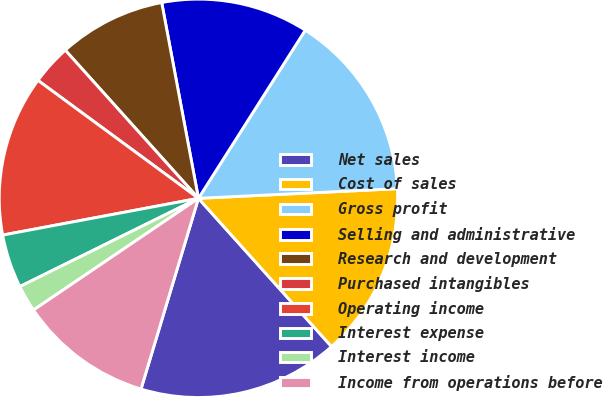<chart> <loc_0><loc_0><loc_500><loc_500><pie_chart><fcel>Net sales<fcel>Cost of sales<fcel>Gross profit<fcel>Selling and administrative<fcel>Research and development<fcel>Purchased intangibles<fcel>Operating income<fcel>Interest expense<fcel>Interest income<fcel>Income from operations before<nl><fcel>16.3%<fcel>14.13%<fcel>15.22%<fcel>11.96%<fcel>8.7%<fcel>3.26%<fcel>13.04%<fcel>4.35%<fcel>2.17%<fcel>10.87%<nl></chart> 